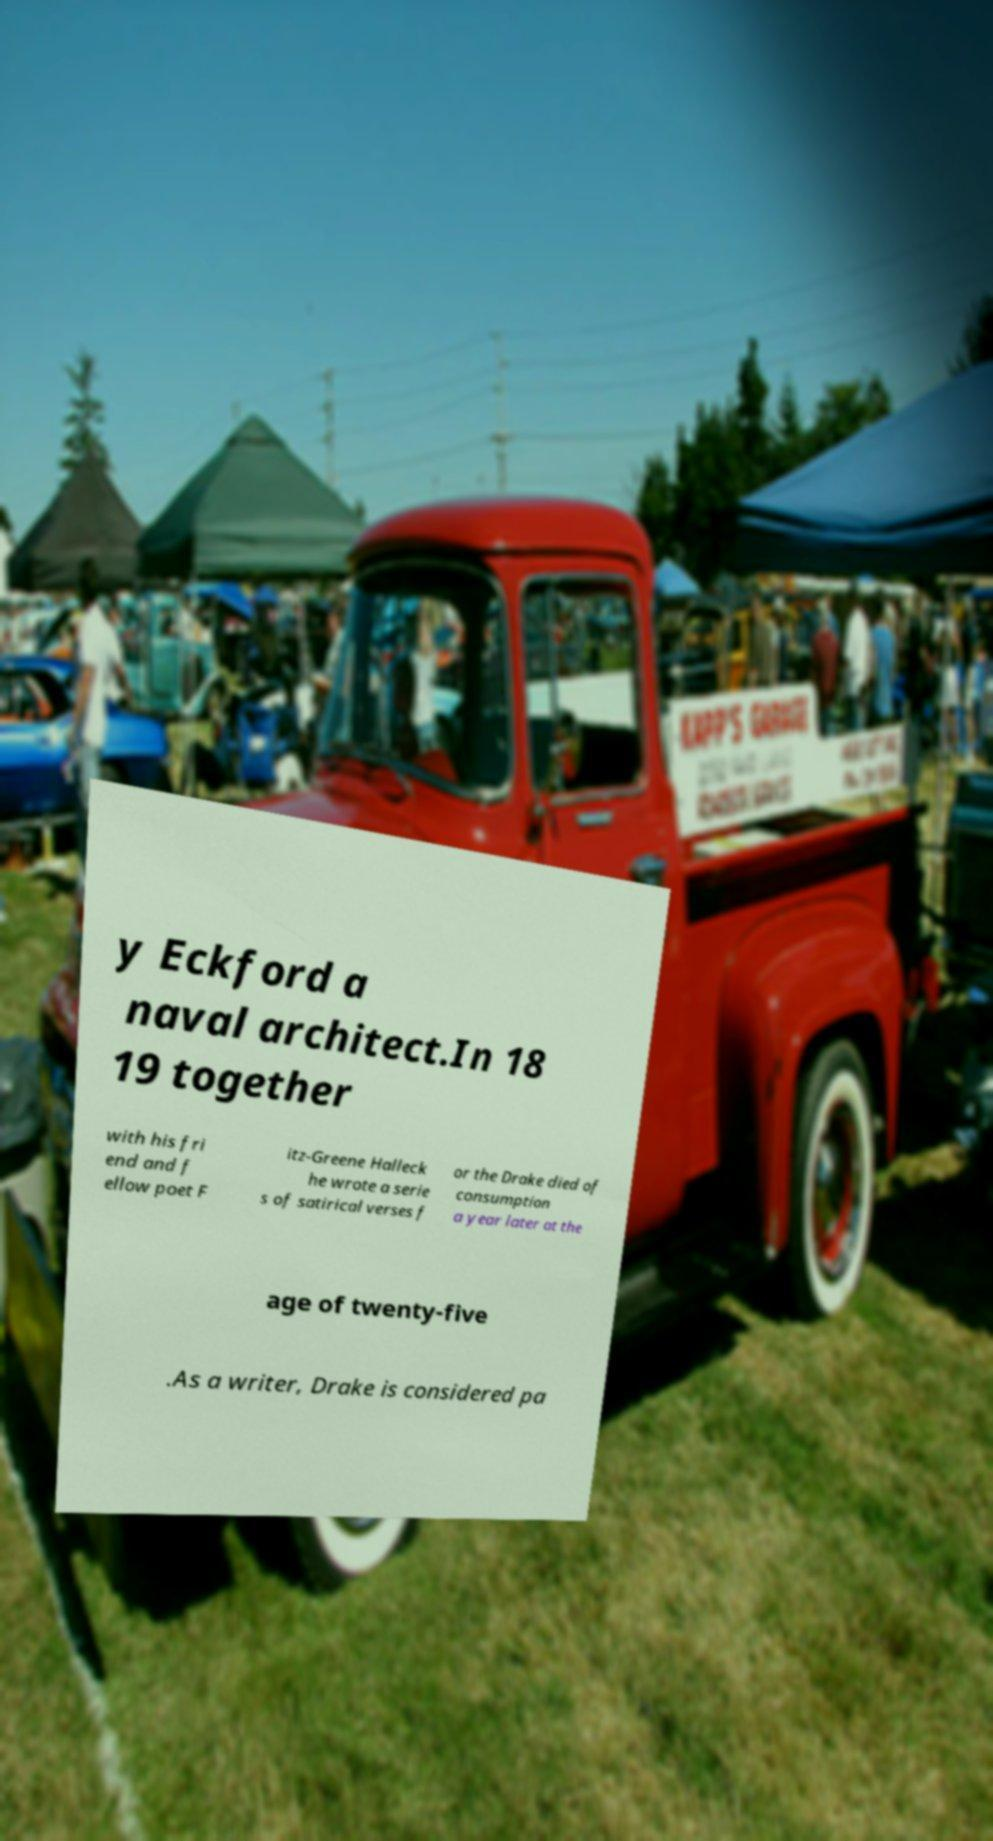Please read and relay the text visible in this image. What does it say? y Eckford a naval architect.In 18 19 together with his fri end and f ellow poet F itz-Greene Halleck he wrote a serie s of satirical verses f or the Drake died of consumption a year later at the age of twenty-five .As a writer, Drake is considered pa 